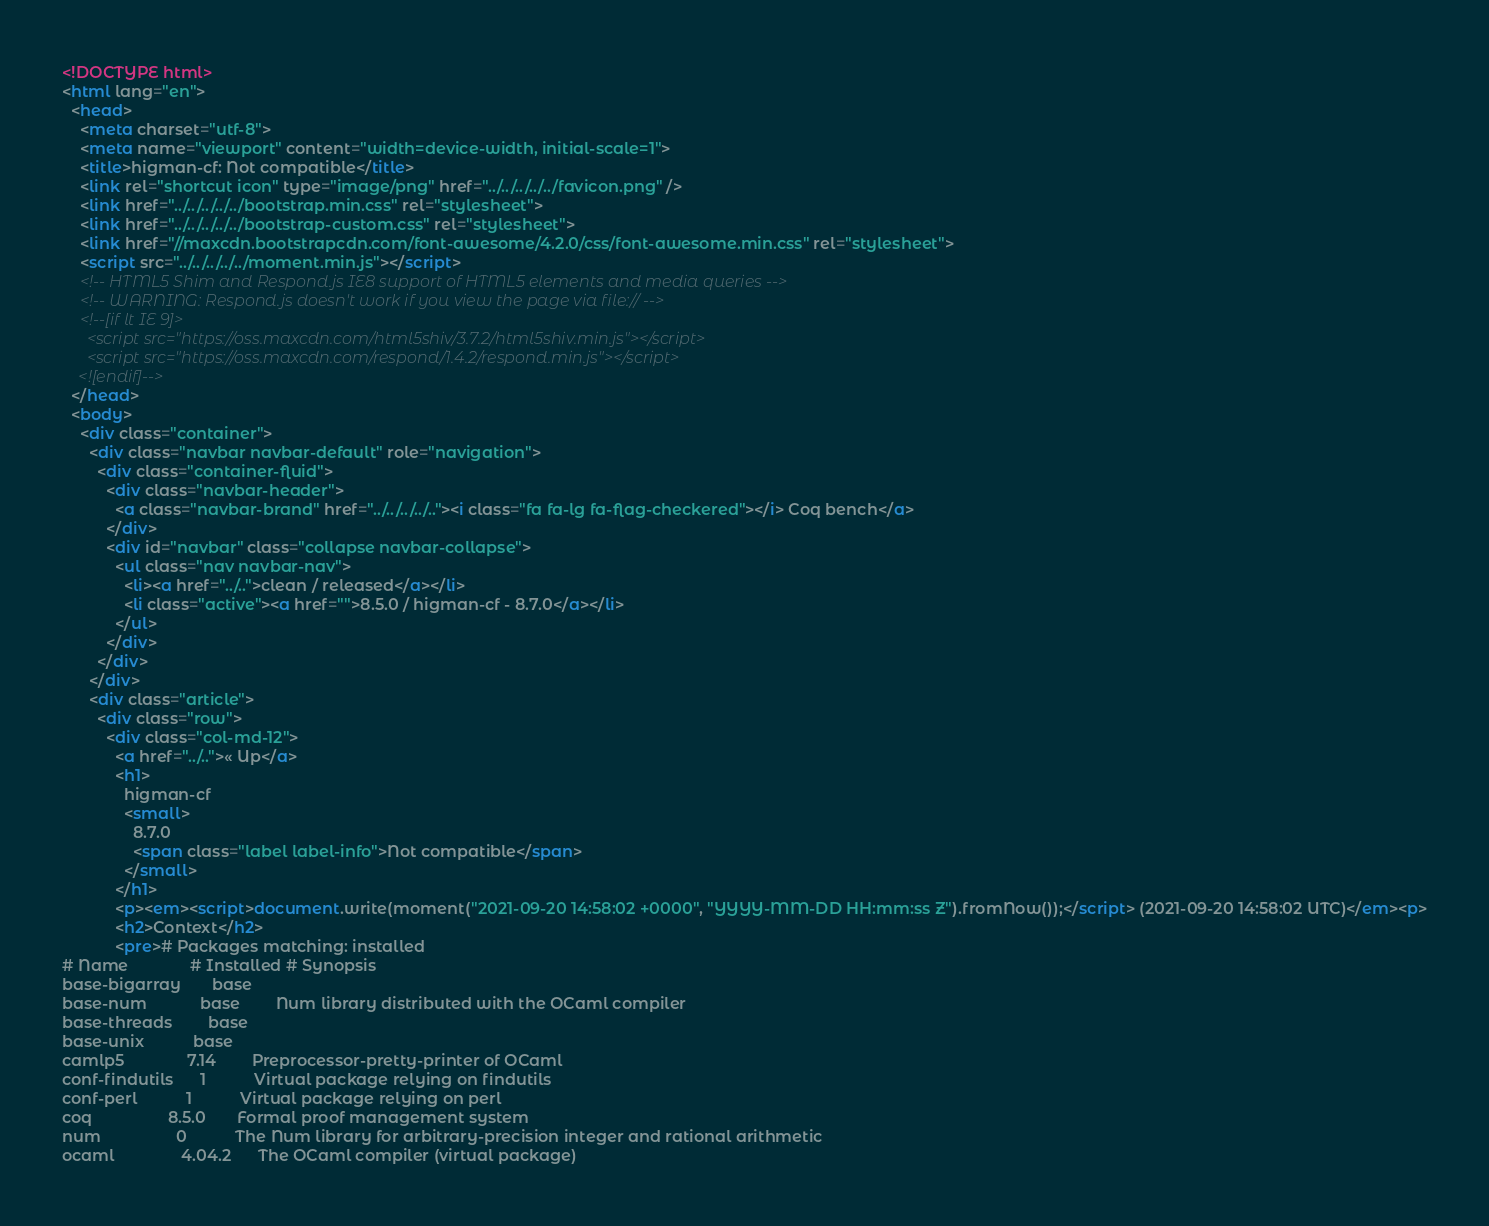<code> <loc_0><loc_0><loc_500><loc_500><_HTML_><!DOCTYPE html>
<html lang="en">
  <head>
    <meta charset="utf-8">
    <meta name="viewport" content="width=device-width, initial-scale=1">
    <title>higman-cf: Not compatible</title>
    <link rel="shortcut icon" type="image/png" href="../../../../../favicon.png" />
    <link href="../../../../../bootstrap.min.css" rel="stylesheet">
    <link href="../../../../../bootstrap-custom.css" rel="stylesheet">
    <link href="//maxcdn.bootstrapcdn.com/font-awesome/4.2.0/css/font-awesome.min.css" rel="stylesheet">
    <script src="../../../../../moment.min.js"></script>
    <!-- HTML5 Shim and Respond.js IE8 support of HTML5 elements and media queries -->
    <!-- WARNING: Respond.js doesn't work if you view the page via file:// -->
    <!--[if lt IE 9]>
      <script src="https://oss.maxcdn.com/html5shiv/3.7.2/html5shiv.min.js"></script>
      <script src="https://oss.maxcdn.com/respond/1.4.2/respond.min.js"></script>
    <![endif]-->
  </head>
  <body>
    <div class="container">
      <div class="navbar navbar-default" role="navigation">
        <div class="container-fluid">
          <div class="navbar-header">
            <a class="navbar-brand" href="../../../../.."><i class="fa fa-lg fa-flag-checkered"></i> Coq bench</a>
          </div>
          <div id="navbar" class="collapse navbar-collapse">
            <ul class="nav navbar-nav">
              <li><a href="../..">clean / released</a></li>
              <li class="active"><a href="">8.5.0 / higman-cf - 8.7.0</a></li>
            </ul>
          </div>
        </div>
      </div>
      <div class="article">
        <div class="row">
          <div class="col-md-12">
            <a href="../..">« Up</a>
            <h1>
              higman-cf
              <small>
                8.7.0
                <span class="label label-info">Not compatible</span>
              </small>
            </h1>
            <p><em><script>document.write(moment("2021-09-20 14:58:02 +0000", "YYYY-MM-DD HH:mm:ss Z").fromNow());</script> (2021-09-20 14:58:02 UTC)</em><p>
            <h2>Context</h2>
            <pre># Packages matching: installed
# Name              # Installed # Synopsis
base-bigarray       base
base-num            base        Num library distributed with the OCaml compiler
base-threads        base
base-unix           base
camlp5              7.14        Preprocessor-pretty-printer of OCaml
conf-findutils      1           Virtual package relying on findutils
conf-perl           1           Virtual package relying on perl
coq                 8.5.0       Formal proof management system
num                 0           The Num library for arbitrary-precision integer and rational arithmetic
ocaml               4.04.2      The OCaml compiler (virtual package)</code> 